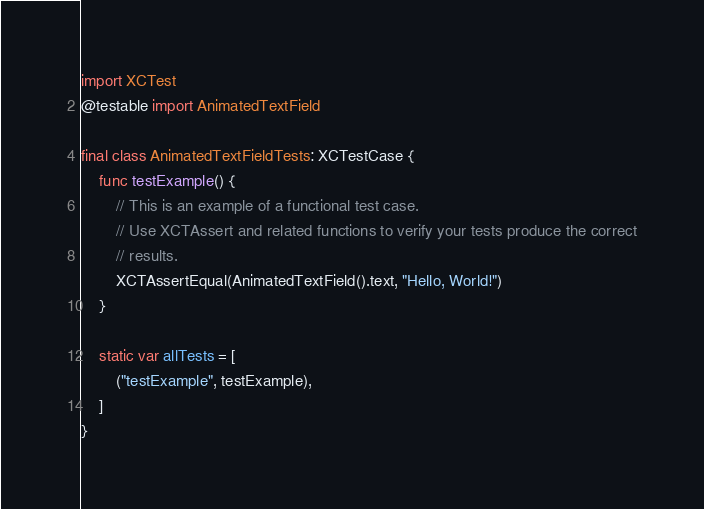<code> <loc_0><loc_0><loc_500><loc_500><_Swift_>import XCTest
@testable import AnimatedTextField

final class AnimatedTextFieldTests: XCTestCase {
    func testExample() {
        // This is an example of a functional test case.
        // Use XCTAssert and related functions to verify your tests produce the correct
        // results.
        XCTAssertEqual(AnimatedTextField().text, "Hello, World!")
    }

    static var allTests = [
        ("testExample", testExample),
    ]
}
</code> 